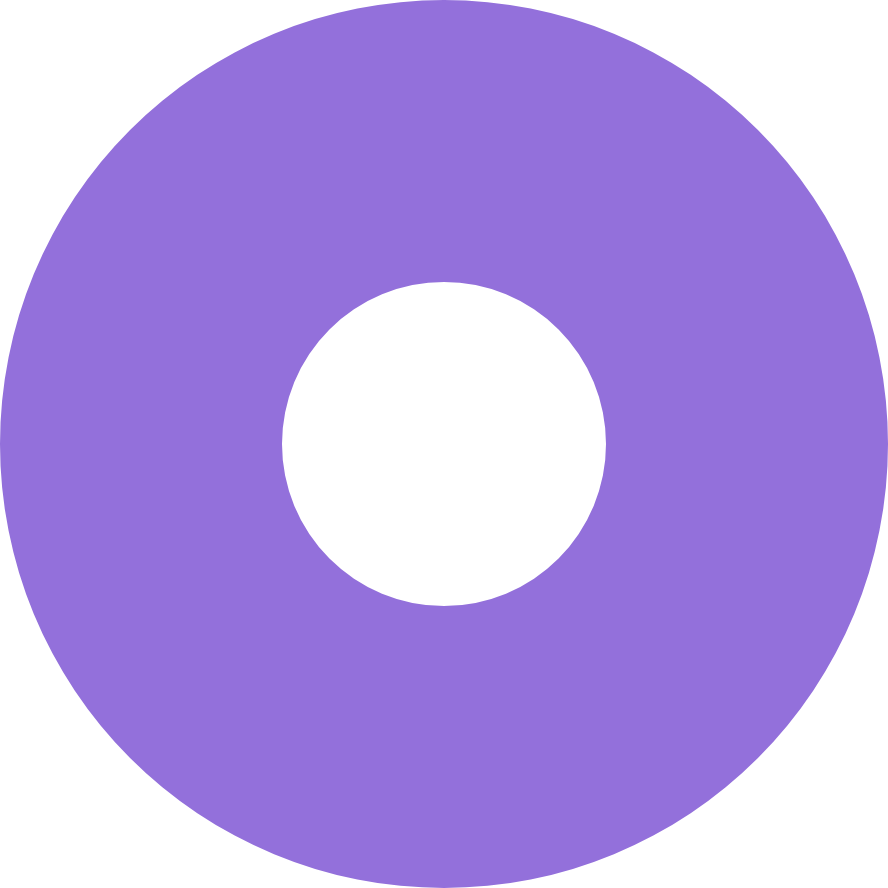Convert chart to OTSL. <chart><loc_0><loc_0><loc_500><loc_500><pie_chart><ecel><nl><fcel>100.0%<nl></chart> 